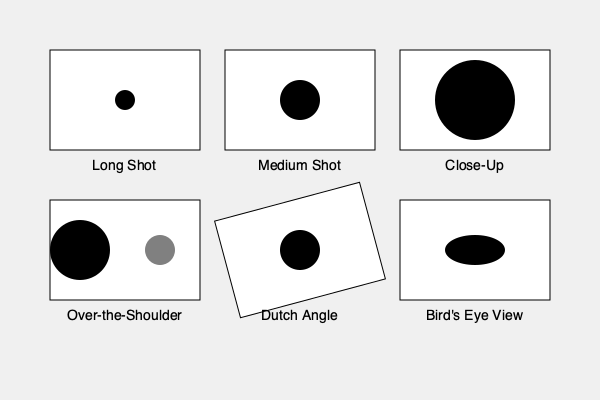As a new anchor, you're learning about camera angles and framing. Which shot composition would be most effective for capturing an intimate emotional moment during an interview, and why? To answer this question, let's analyze each shot composition in the diagram:

1. Long Shot: This shows the entire subject and their surroundings. It's good for establishing a scene but lacks emotional intimacy.

2. Medium Shot: Frames the subject from the waist up. It's more personal than a long shot but still maintains some distance.

3. Close-Up: Focuses on the subject's face, filling most of the frame. This shot is ideal for capturing emotions and creating intimacy with the viewer.

4. Over-the-Shoulder: Shows one person from behind the shoulder of another. It's useful for conveying conversation but doesn't focus solely on emotions.

5. Dutch Angle: A tilted camera angle that can create tension or unease. It's not typically used for emotional interviews.

6. Bird's Eye View: A shot from directly above the subject. While interesting, it doesn't capture facial expressions well.

For capturing an intimate emotional moment during an interview, the Close-Up shot would be most effective. This is because:

a) It focuses on the subject's face, allowing viewers to see subtle emotional expressions.
b) It creates a sense of intimacy by bringing the viewer close to the subject.
c) It eliminates distractions from the background, keeping the focus on the person's emotions.
d) In television, close-ups are often used to convey emotional impact and connect the audience with the subject.

As a new anchor, understanding the power of the close-up shot for emotional moments will help you work effectively with your camera crew to capture compelling interviews.
Answer: Close-Up shot 